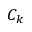<formula> <loc_0><loc_0><loc_500><loc_500>C _ { k }</formula> 